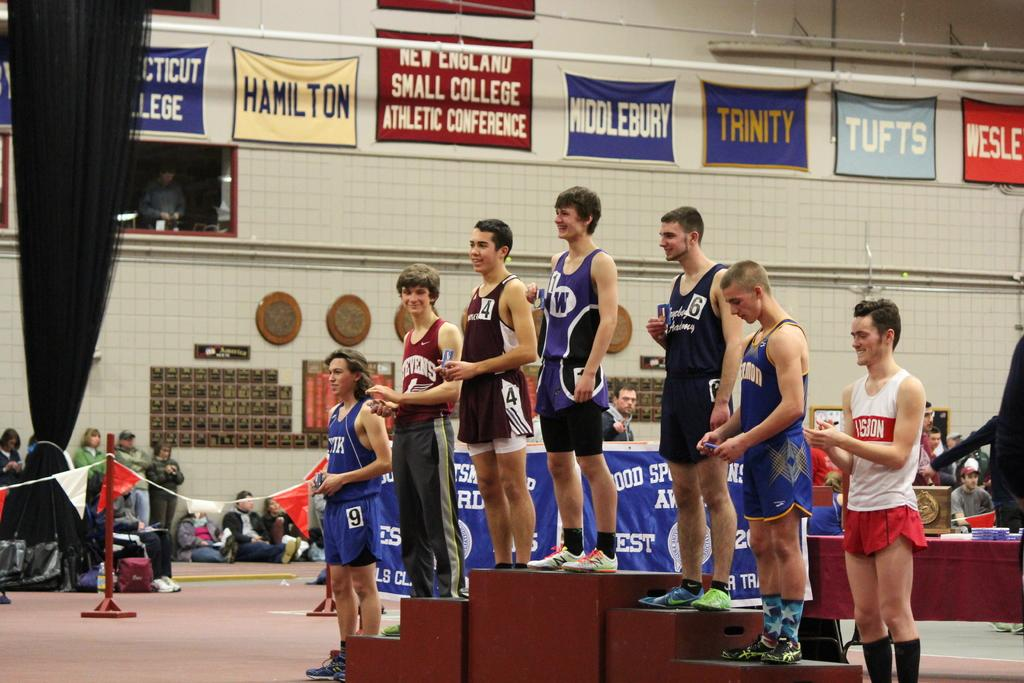<image>
Present a compact description of the photo's key features. Athletes stand on a podium with manes of colleges lining the gym walls 